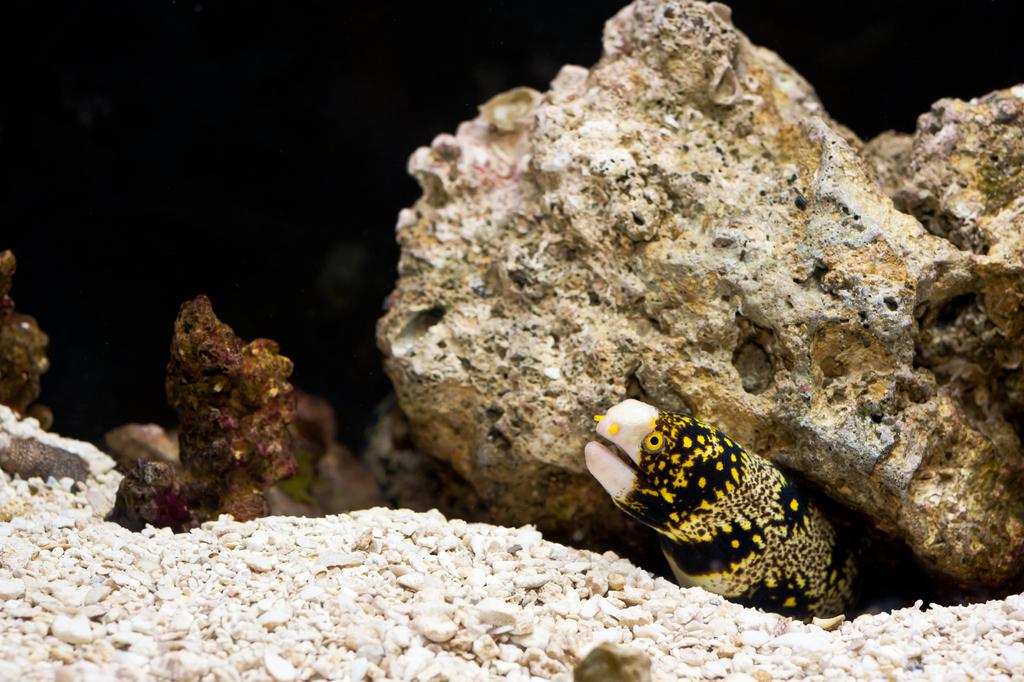What type of animal is at the bottom of the image? There is an animal at the bottom of the image, but the specific type cannot be determined from the provided facts. How many animals are visible in the image? There are other animals in the middle and bottom of the image, but the exact number cannot be determined from the provided facts. What type of stove can be seen in the image? There is no stove present in the image; it features animals at the bottom and in the middle. Can you describe the roof of the building in the image? There is no building or roof present in the image; it features animals at the bottom and in the middle. 